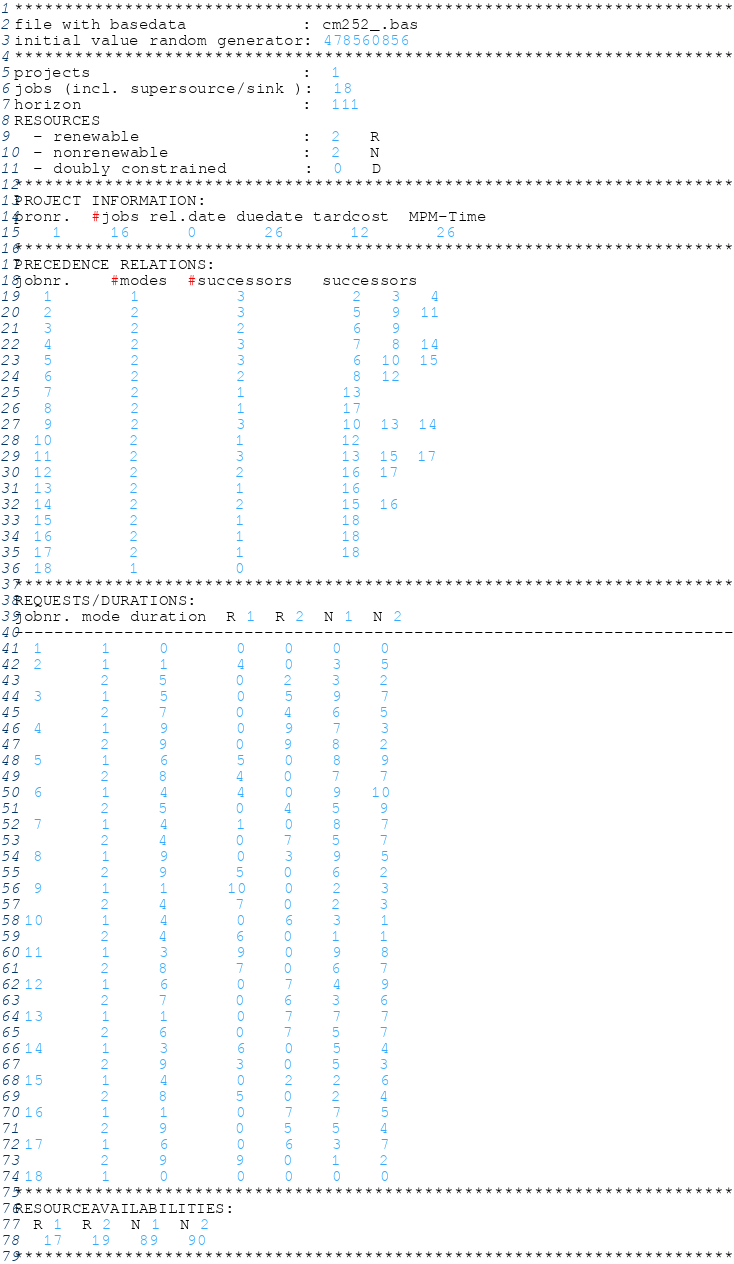Convert code to text. <code><loc_0><loc_0><loc_500><loc_500><_ObjectiveC_>************************************************************************
file with basedata            : cm252_.bas
initial value random generator: 478560856
************************************************************************
projects                      :  1
jobs (incl. supersource/sink ):  18
horizon                       :  111
RESOURCES
  - renewable                 :  2   R
  - nonrenewable              :  2   N
  - doubly constrained        :  0   D
************************************************************************
PROJECT INFORMATION:
pronr.  #jobs rel.date duedate tardcost  MPM-Time
    1     16      0       26       12       26
************************************************************************
PRECEDENCE RELATIONS:
jobnr.    #modes  #successors   successors
   1        1          3           2   3   4
   2        2          3           5   9  11
   3        2          2           6   9
   4        2          3           7   8  14
   5        2          3           6  10  15
   6        2          2           8  12
   7        2          1          13
   8        2          1          17
   9        2          3          10  13  14
  10        2          1          12
  11        2          3          13  15  17
  12        2          2          16  17
  13        2          1          16
  14        2          2          15  16
  15        2          1          18
  16        2          1          18
  17        2          1          18
  18        1          0        
************************************************************************
REQUESTS/DURATIONS:
jobnr. mode duration  R 1  R 2  N 1  N 2
------------------------------------------------------------------------
  1      1     0       0    0    0    0
  2      1     1       4    0    3    5
         2     5       0    2    3    2
  3      1     5       0    5    9    7
         2     7       0    4    6    5
  4      1     9       0    9    7    3
         2     9       0    9    8    2
  5      1     6       5    0    8    9
         2     8       4    0    7    7
  6      1     4       4    0    9   10
         2     5       0    4    5    9
  7      1     4       1    0    8    7
         2     4       0    7    5    7
  8      1     9       0    3    9    5
         2     9       5    0    6    2
  9      1     1      10    0    2    3
         2     4       7    0    2    3
 10      1     4       0    6    3    1
         2     4       6    0    1    1
 11      1     3       9    0    9    8
         2     8       7    0    6    7
 12      1     6       0    7    4    9
         2     7       0    6    3    6
 13      1     1       0    7    7    7
         2     6       0    7    5    7
 14      1     3       6    0    5    4
         2     9       3    0    5    3
 15      1     4       0    2    2    6
         2     8       5    0    2    4
 16      1     1       0    7    7    5
         2     9       0    5    5    4
 17      1     6       0    6    3    7
         2     9       9    0    1    2
 18      1     0       0    0    0    0
************************************************************************
RESOURCEAVAILABILITIES:
  R 1  R 2  N 1  N 2
   17   19   89   90
************************************************************************
</code> 